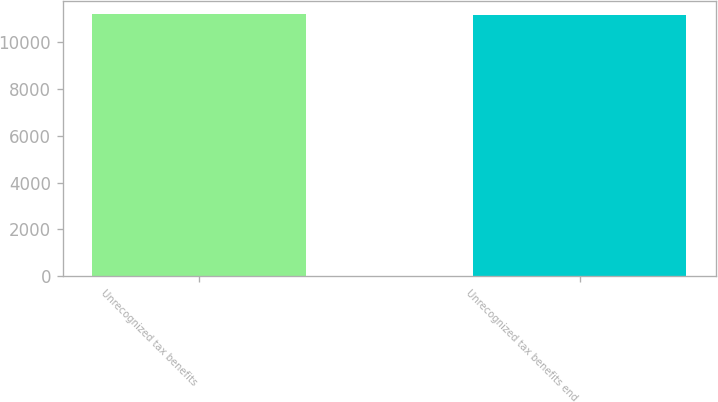Convert chart. <chart><loc_0><loc_0><loc_500><loc_500><bar_chart><fcel>Unrecognized tax benefits<fcel>Unrecognized tax benefits end<nl><fcel>11174<fcel>11144<nl></chart> 